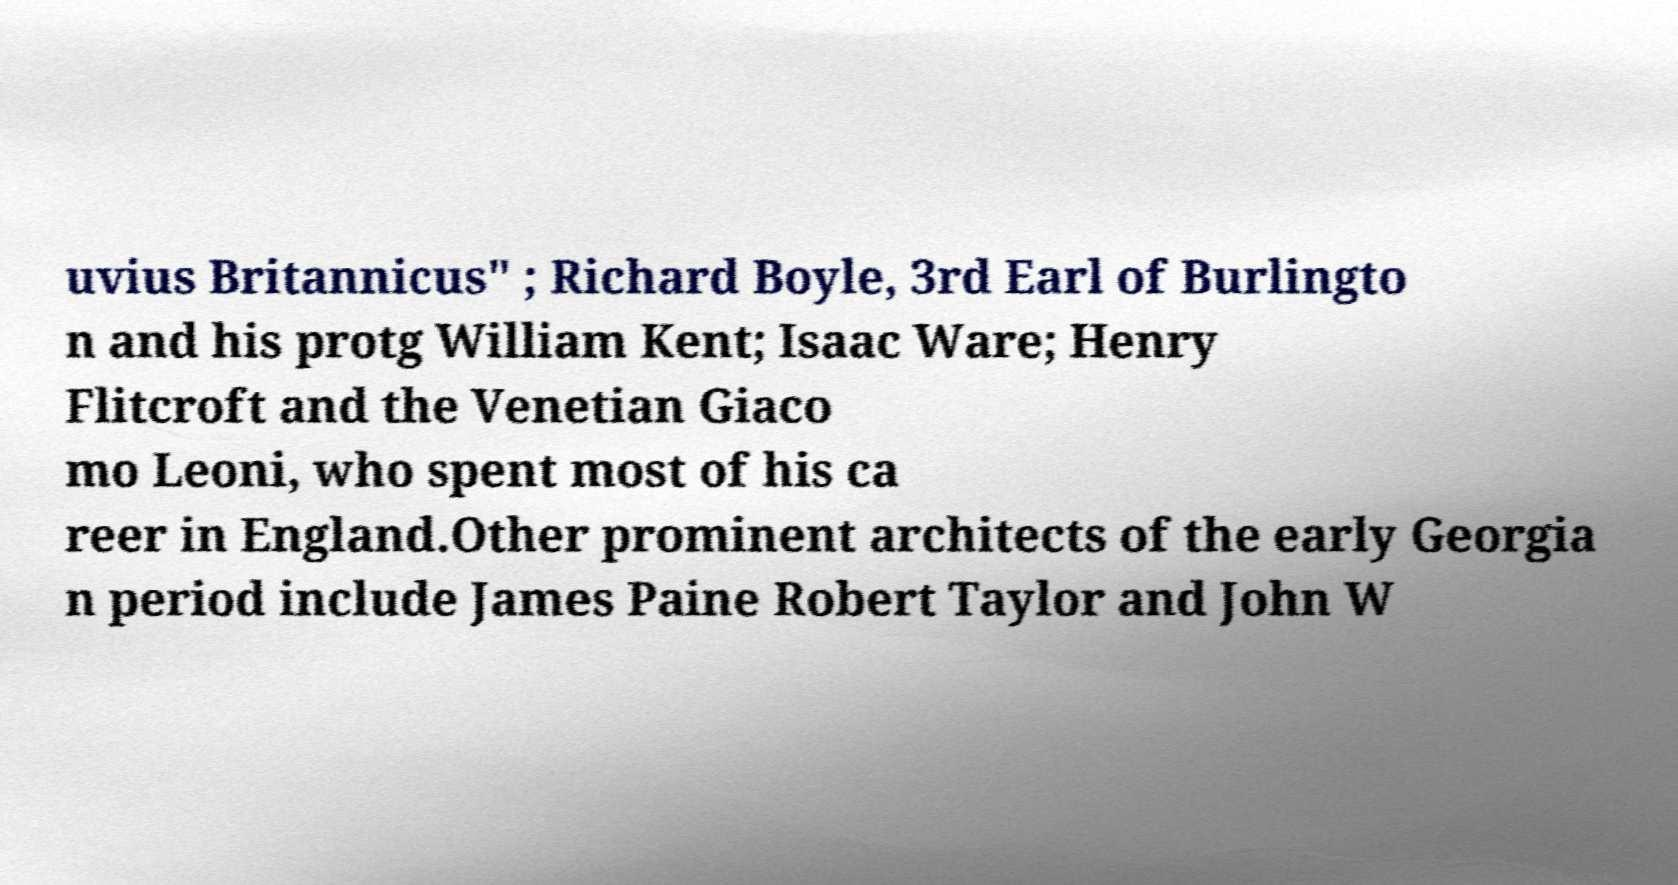Can you accurately transcribe the text from the provided image for me? uvius Britannicus" ; Richard Boyle, 3rd Earl of Burlingto n and his protg William Kent; Isaac Ware; Henry Flitcroft and the Venetian Giaco mo Leoni, who spent most of his ca reer in England.Other prominent architects of the early Georgia n period include James Paine Robert Taylor and John W 